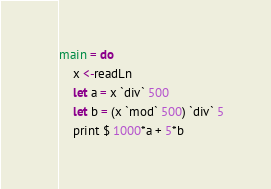<code> <loc_0><loc_0><loc_500><loc_500><_Haskell_>main = do
    x <-readLn
    let a = x `div` 500
    let b = (x `mod` 500) `div` 5
    print $ 1000*a + 5*b</code> 